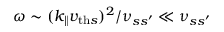<formula> <loc_0><loc_0><loc_500><loc_500>\omega \sim ( k _ { \| } v _ { t h s } ) ^ { 2 } / \nu _ { s s ^ { \prime } } \ll \nu _ { s s ^ { \prime } }</formula> 